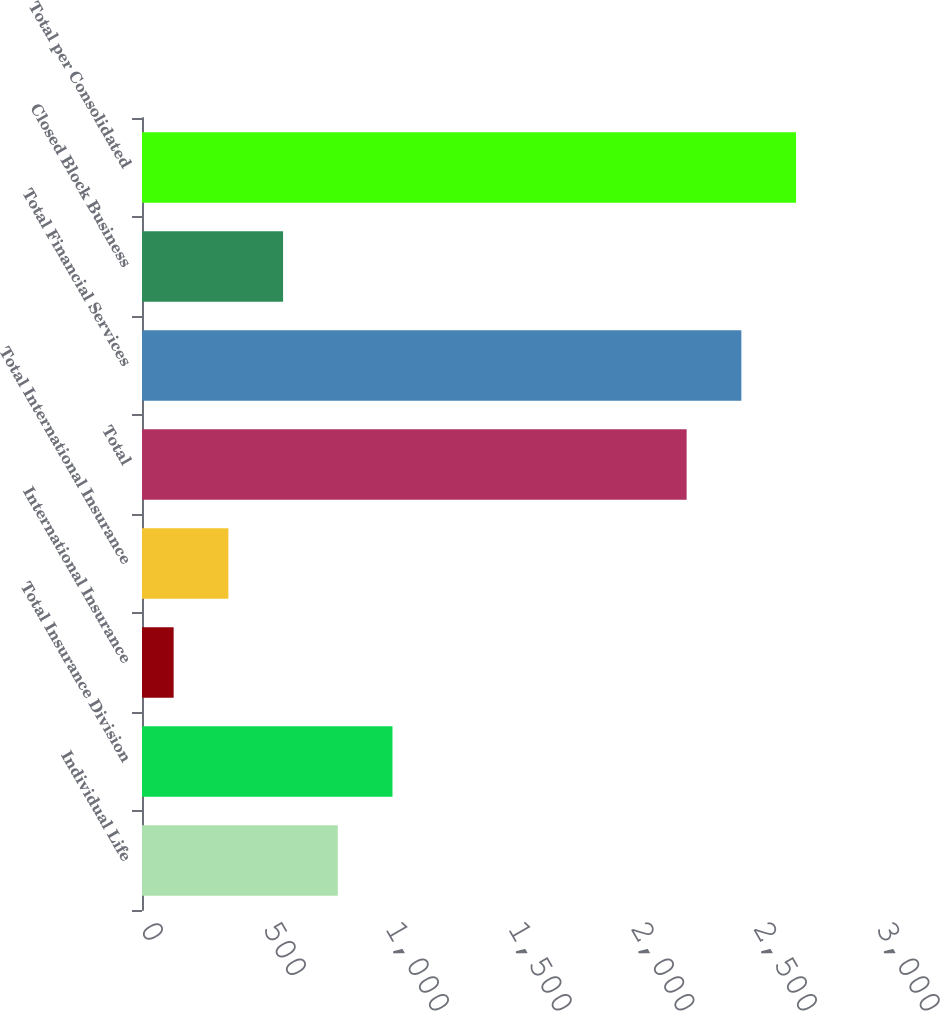Convert chart to OTSL. <chart><loc_0><loc_0><loc_500><loc_500><bar_chart><fcel>Individual Life<fcel>Total Insurance Division<fcel>International Insurance<fcel>Total International Insurance<fcel>Total<fcel>Total Financial Services<fcel>Closed Block Business<fcel>Total per Consolidated<nl><fcel>798<fcel>1021<fcel>129<fcel>352<fcel>2220<fcel>2443<fcel>575<fcel>2666<nl></chart> 